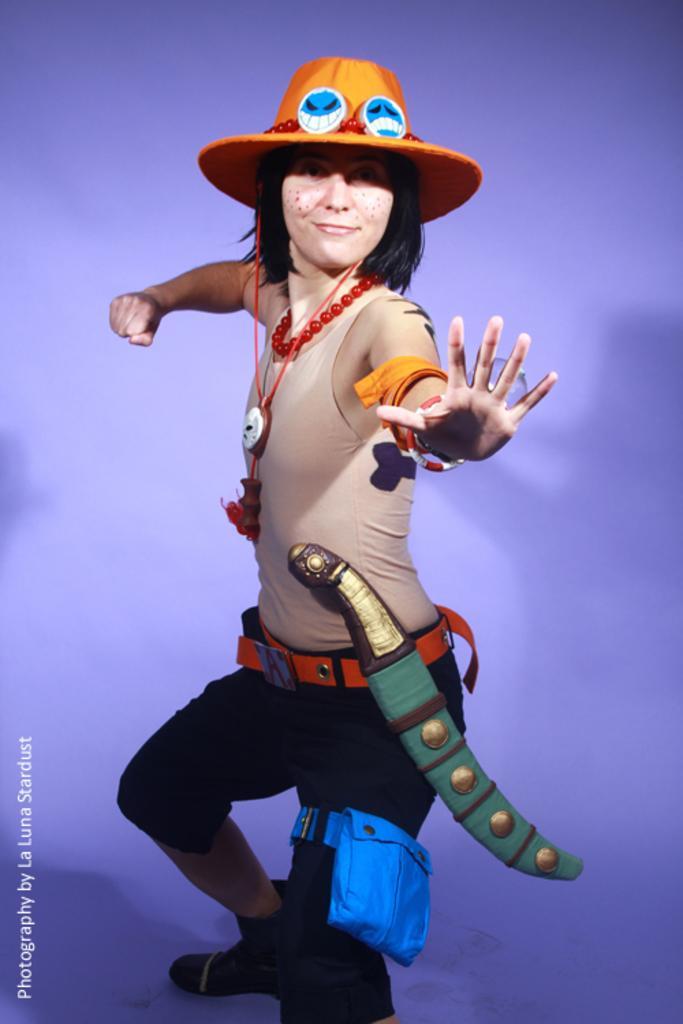Can you describe this image briefly? In this image we can see a woman standing on the surface wearing the costume. 